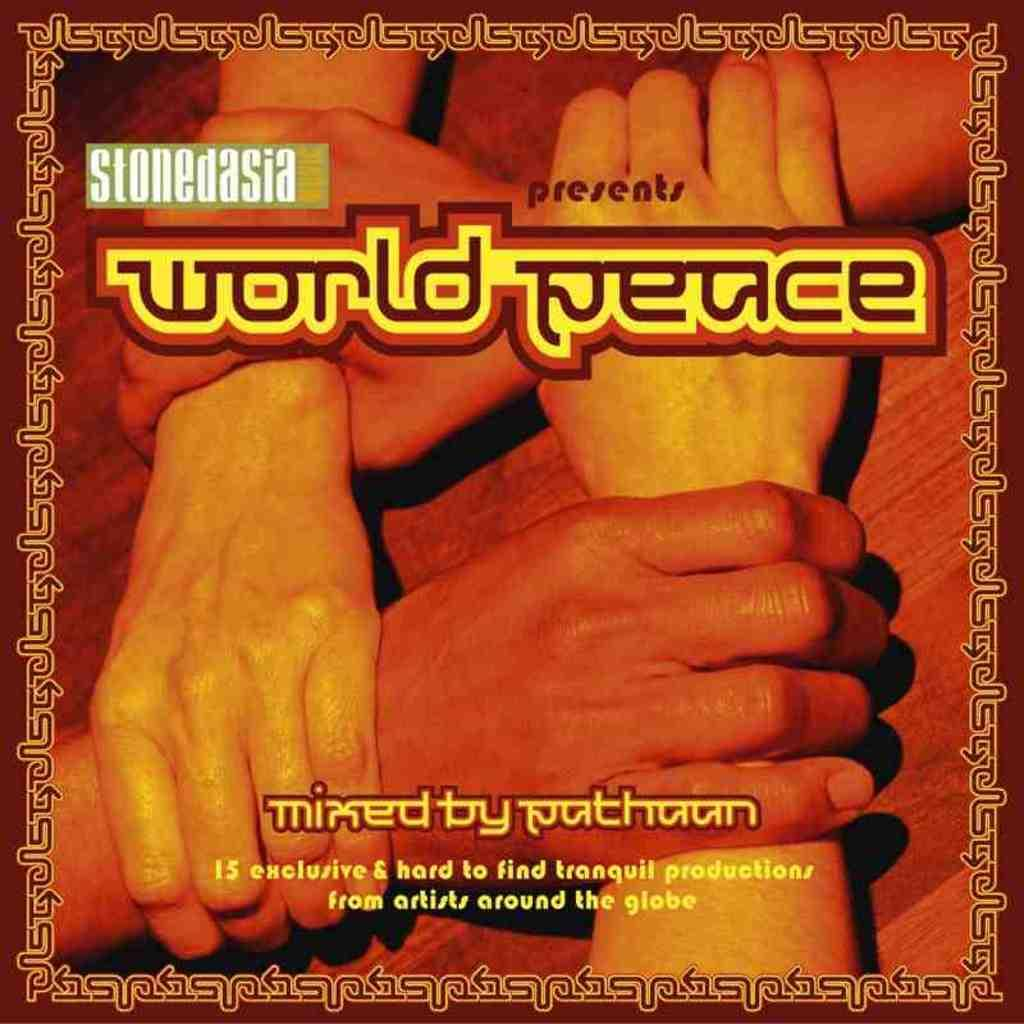What is the main subject of the image? The main subject of the image is a poster. What is depicted on the poster? The poster contains four hands on a brown color surface. Is there any text on the poster? Yes, there is a name written on the poster. What time of day is it in the image, and are there any cherries present? The time of day is not mentioned in the image, and there are no cherries present. What type of class is being taught in the image? There is no class or any indication of a class being taught in the image. 